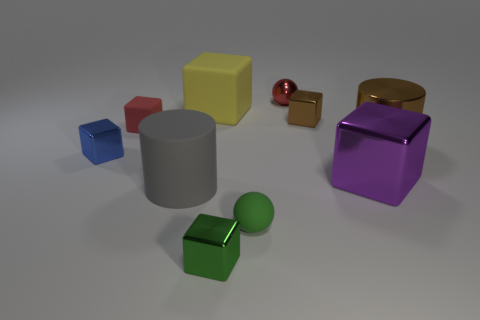Are there fewer red blocks than small yellow objects?
Provide a succinct answer. No. There is a metallic object in front of the gray object; is it the same color as the matte cylinder?
Provide a succinct answer. No. There is a red thing on the right side of the large cylinder that is left of the tiny metal object that is right of the red sphere; what is it made of?
Ensure brevity in your answer.  Metal. Is there a small metallic block that has the same color as the matte ball?
Offer a very short reply. Yes. Are there fewer matte things that are behind the tiny red rubber block than brown metallic things?
Provide a short and direct response. Yes. Is the size of the sphere that is behind the blue cube the same as the purple metal thing?
Provide a succinct answer. No. How many objects are on the left side of the small green rubber thing and in front of the small brown object?
Your answer should be compact. 4. How big is the cylinder that is in front of the cylinder right of the matte ball?
Offer a terse response. Large. Are there fewer things behind the metal cylinder than small red objects that are in front of the yellow rubber cube?
Give a very brief answer. No. Does the tiny metallic thing behind the small brown block have the same color as the tiny rubber object to the left of the green metallic cube?
Your answer should be very brief. Yes. 